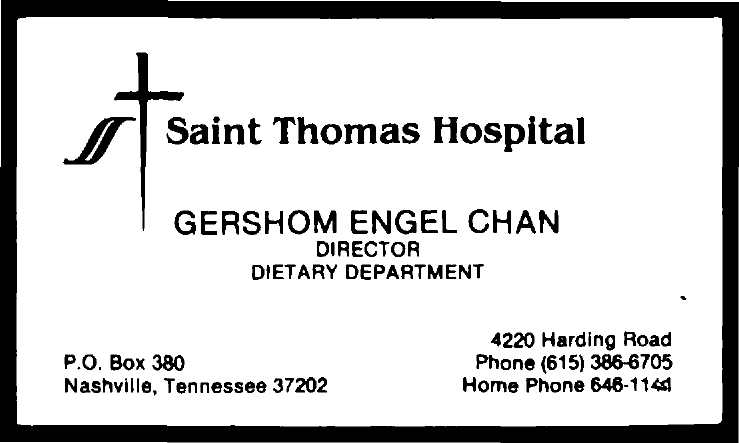Identify some key points in this picture. Gershom Engel Chan is the name of the director. The name of the department is the Dietary department. Saint Thomas Hospital is the name of a hospital. 